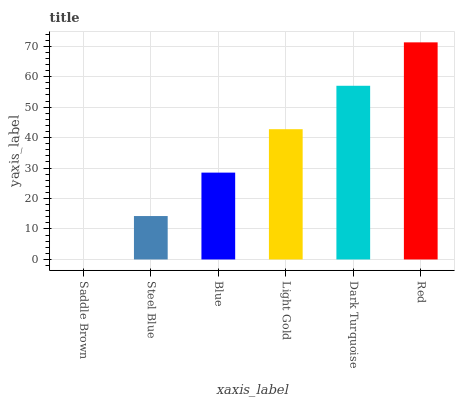Is Saddle Brown the minimum?
Answer yes or no. Yes. Is Red the maximum?
Answer yes or no. Yes. Is Steel Blue the minimum?
Answer yes or no. No. Is Steel Blue the maximum?
Answer yes or no. No. Is Steel Blue greater than Saddle Brown?
Answer yes or no. Yes. Is Saddle Brown less than Steel Blue?
Answer yes or no. Yes. Is Saddle Brown greater than Steel Blue?
Answer yes or no. No. Is Steel Blue less than Saddle Brown?
Answer yes or no. No. Is Light Gold the high median?
Answer yes or no. Yes. Is Blue the low median?
Answer yes or no. Yes. Is Steel Blue the high median?
Answer yes or no. No. Is Saddle Brown the low median?
Answer yes or no. No. 